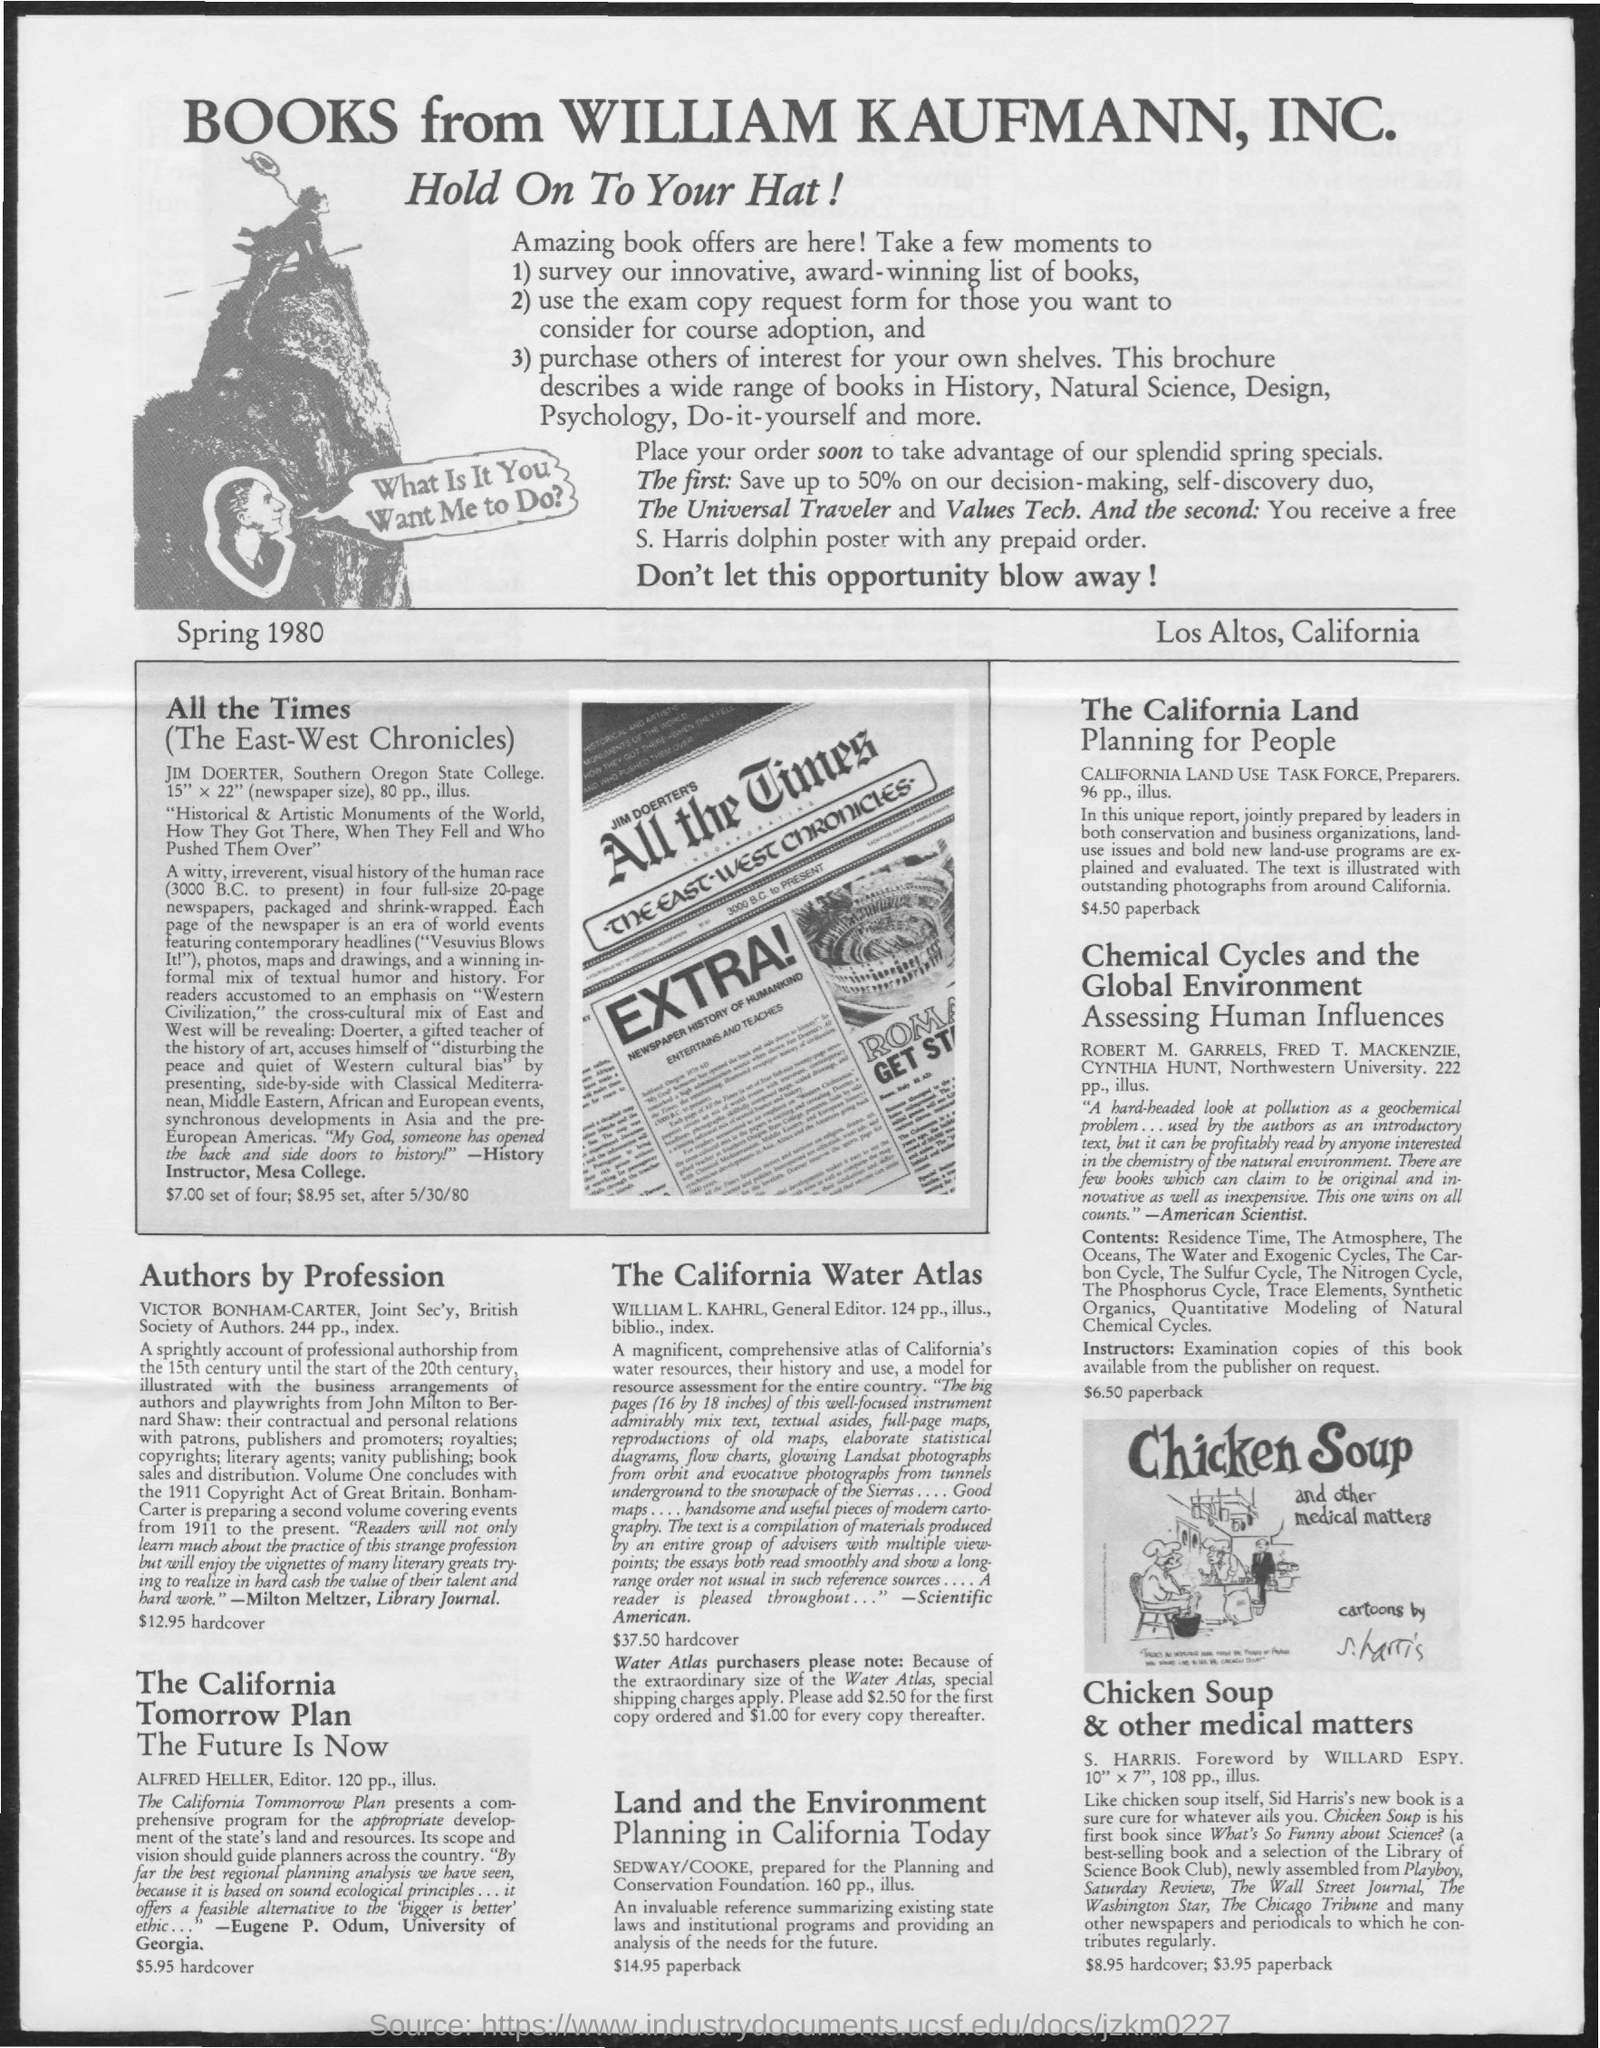What is the first title in the document?
Offer a very short reply. BOOKS FROM WILLIAM KAUFMANN, INC. What is the second title in the document?
Your answer should be compact. Hold on to your hat!. 